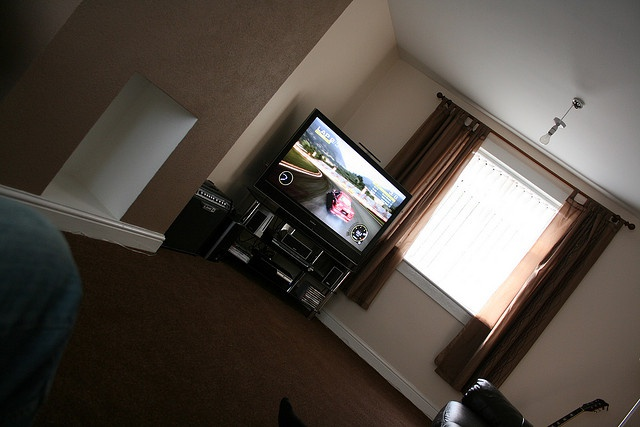Describe the objects in this image and their specific colors. I can see tv in black, white, gray, and darkgray tones, people in black and purple tones, couch in black, lavender, gray, and darkgray tones, and car in black, lavender, and lightpink tones in this image. 